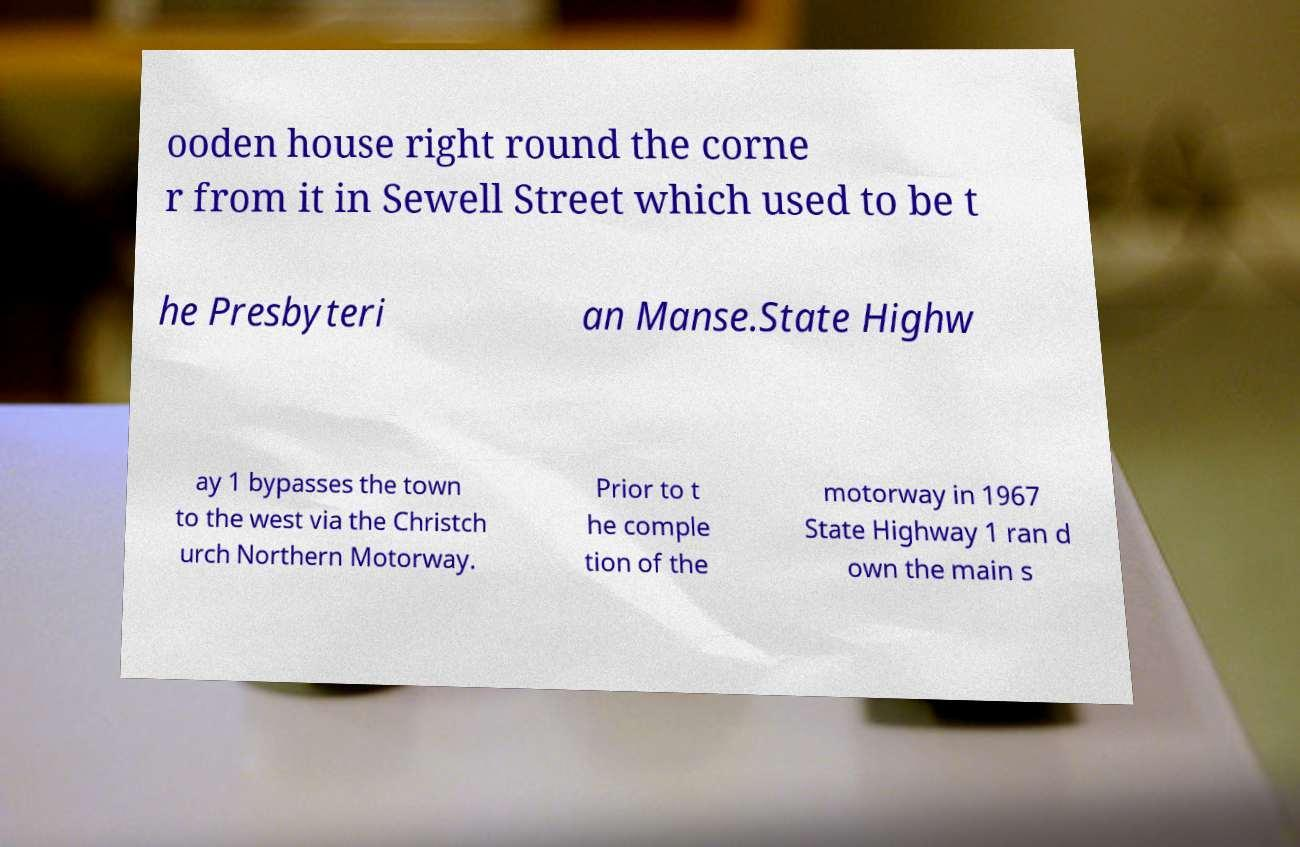I need the written content from this picture converted into text. Can you do that? ooden house right round the corne r from it in Sewell Street which used to be t he Presbyteri an Manse.State Highw ay 1 bypasses the town to the west via the Christch urch Northern Motorway. Prior to t he comple tion of the motorway in 1967 State Highway 1 ran d own the main s 